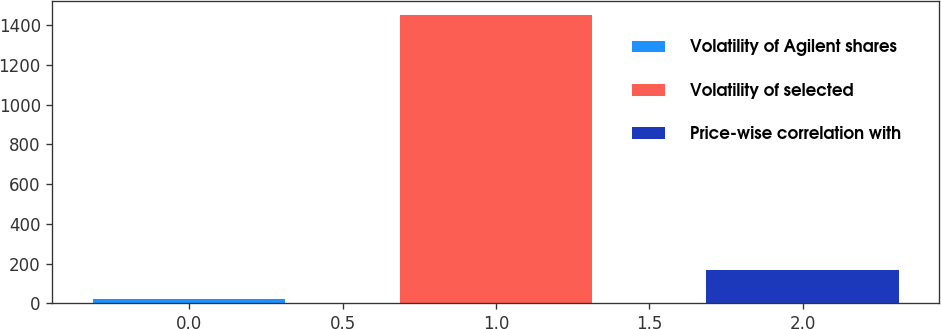<chart> <loc_0><loc_0><loc_500><loc_500><bar_chart><fcel>Volatility of Agilent shares<fcel>Volatility of selected<fcel>Price-wise correlation with<nl><fcel>24<fcel>1450<fcel>166.6<nl></chart> 